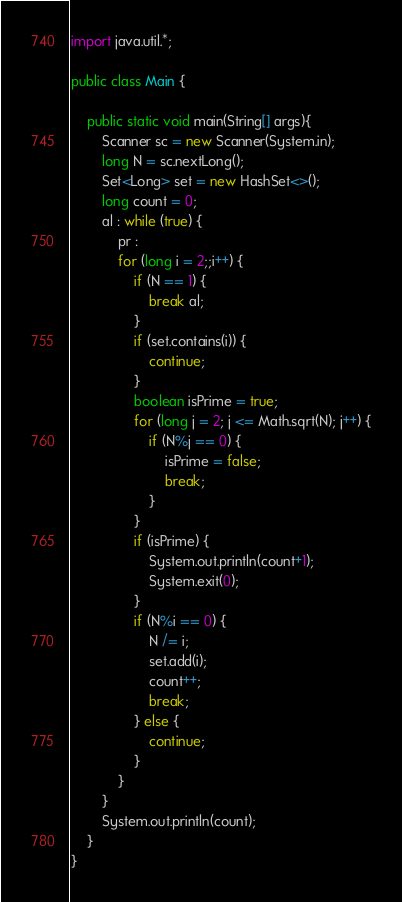Convert code to text. <code><loc_0><loc_0><loc_500><loc_500><_Java_>import java.util.*;
 
public class Main {
 
	public static void main(String[] args){
		Scanner sc = new Scanner(System.in);
		long N = sc.nextLong();
		Set<Long> set = new HashSet<>();
		long count = 0;
		al : while (true) {
			pr :
			for (long i = 2;;i++) {
				if (N == 1) {
					break al;
				}
				if (set.contains(i)) {
					continue;
				}
				boolean isPrime = true;
				for (long j = 2; j <= Math.sqrt(N); j++) {
					if (N%j == 0) {
						isPrime = false;
						break;
					}
				}
				if (isPrime) {
					System.out.println(count+1);
					System.exit(0);
				}
				if (N%i == 0) {
					N /= i;
					set.add(i);
					count++;
					break;
				} else {
					continue;
				}
			}
		}
		System.out.println(count);
	}
}</code> 